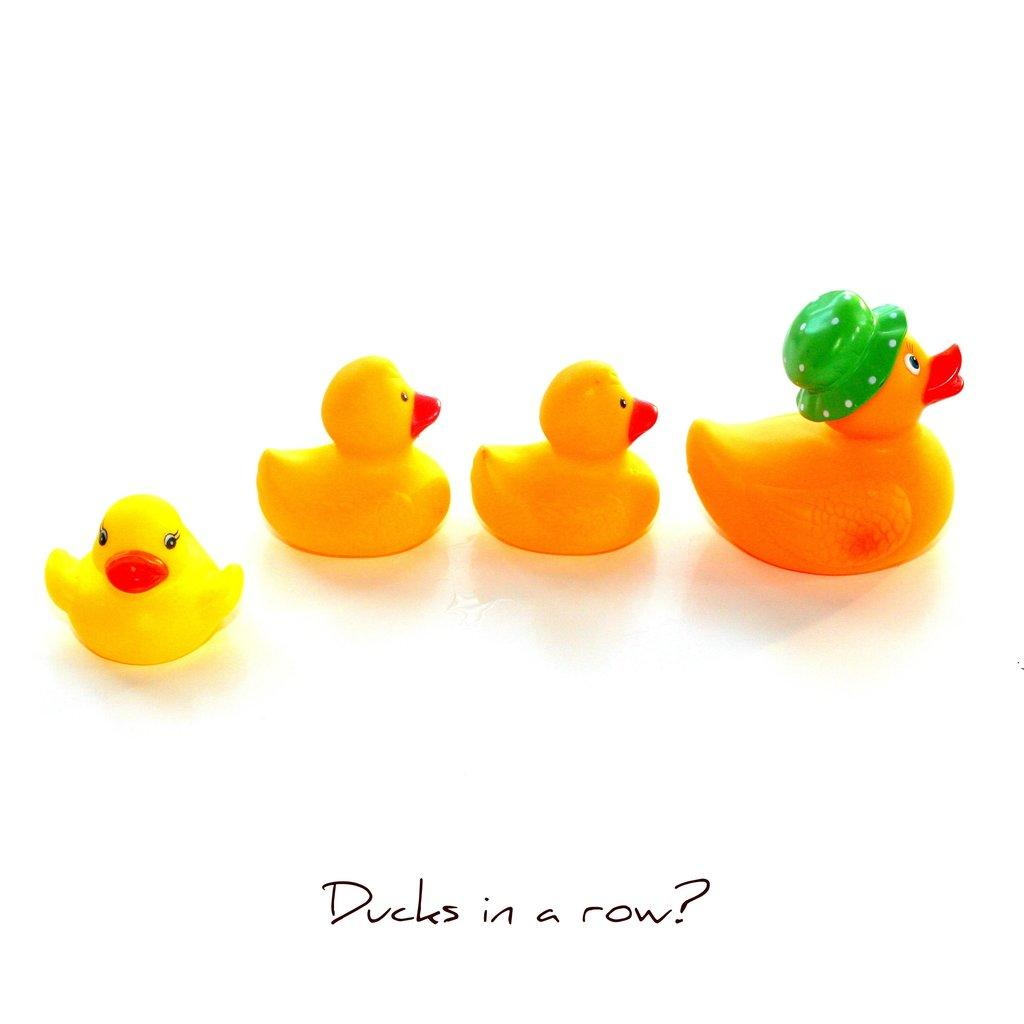What objects are present in the image? There are four toy ducks in the image. What is the color of the background in the image? The background in the image is white. Is there any text visible in the image? Yes, there is some text written at the bottom of the image. How many apples are on the toy ducks' heads in the image? There are no apples present in the image, and none are depicted on the toy ducks' heads. 